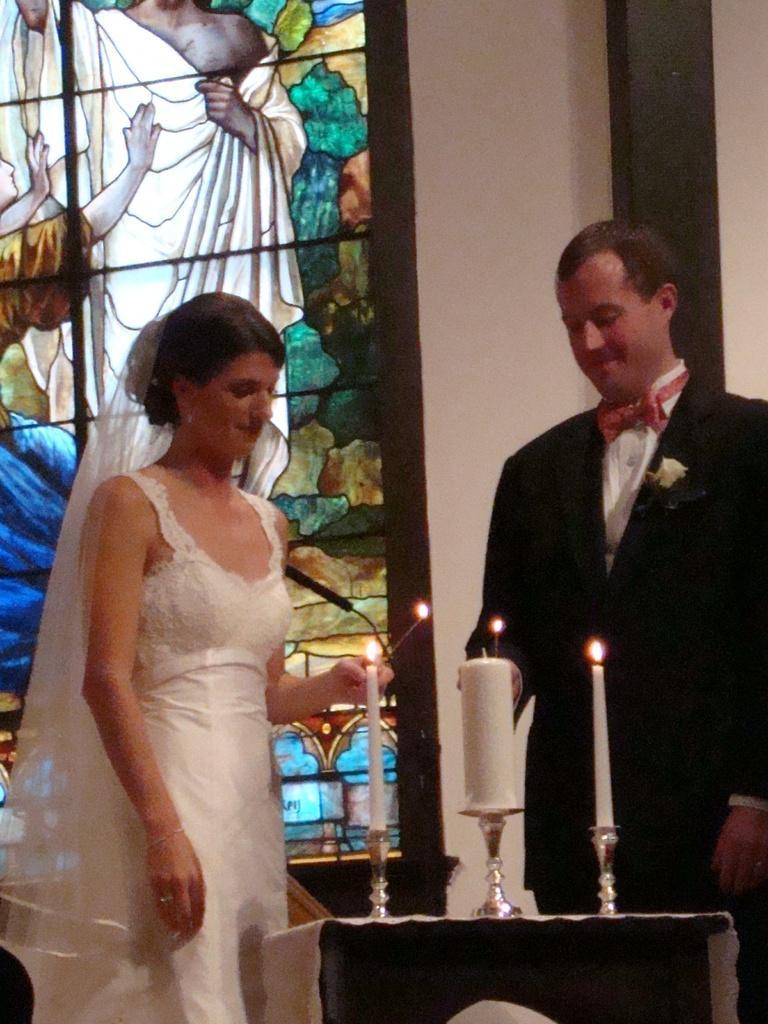Please provide a concise description of this image. In this image I can see two persons standing. The person at right wearing black blazer, white shirt. the person at left wearing white color dress, in front I can see few candles. Background I can see glass wall and I can see the other wall in white color. 